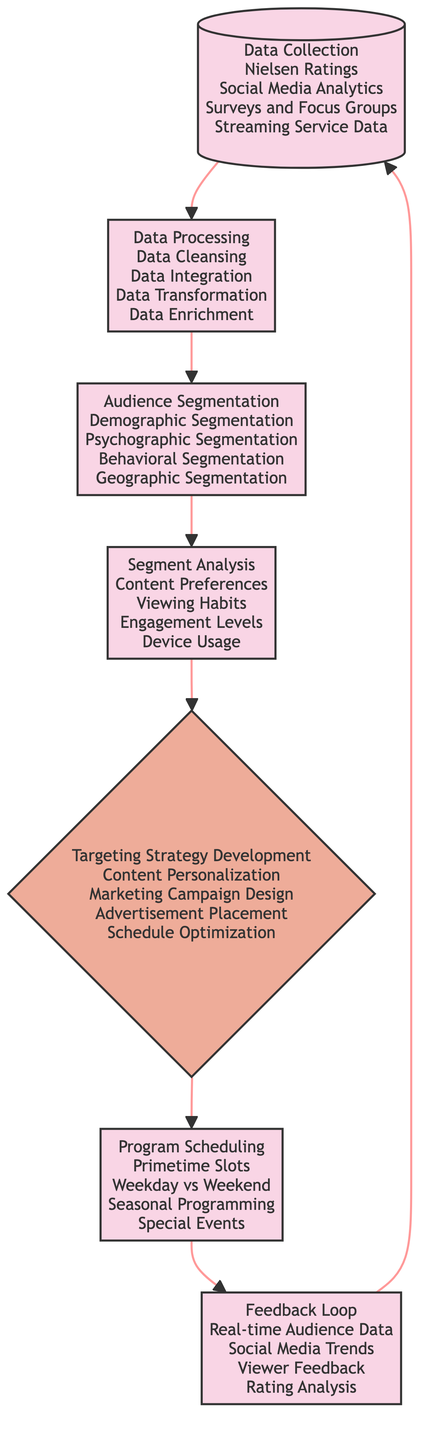What is the first step in the flowchart? The first step in the flowchart is represented by the node labeled "Data Collection," which indicates the initial phase of gathering data from various sources.
Answer: Data Collection How many total processes are in the flowchart? By counting the nodes marked as processes, there are five processes: Data Collection, Data Processing, Audience Segmentation, Segment Analysis, Program Scheduling, and Feedback Loop.
Answer: Five What types of segmentation are included in the Audience Segmentation step? The Audience Segmentation step includes four types of segmentation: Demographic Segmentation, Psychographic Segmentation, Behavioral Segmentation, and Geographic Segmentation, according to the details provided around that node.
Answer: Demographic Segmentation, Psychographic Segmentation, Behavioral Segmentation, Geographic Segmentation What type of node is "Targeting Strategy Development"? The "Targeting Strategy Development" node is labeled as a decision type, which indicates that a strategy is being developed based on the audience segments analyzed.
Answer: Decision What follows the Segment Analysis step in the flowchart? The Segment Analysis step is immediately followed by the Targeting Strategy Development step in the flowchart's sequence, showing the progression from analyzing segments to devising strategies for those segments.
Answer: Targeting Strategy Development Which process incorporates feedback into ongoing strategies? The Feedback Loop process is the one that incorporates real-time audience data, social media trends, viewer feedback, and rating analysis back into the ongoing strategies for program management.
Answer: Feedback Loop What is the final node in the flow of steps? The final node in the flow is the Feedback Loop, which indicates the cyclical nature of the evaluation process in the identification and targeting strategy.
Answer: Feedback Loop What are the two main components of the Program Scheduling process? The Program Scheduling process focuses on scheduling programs around Primetime Slots and the difference between Weekday and Weekend programming.
Answer: Primetime Slots, Weekday vs Weekend 